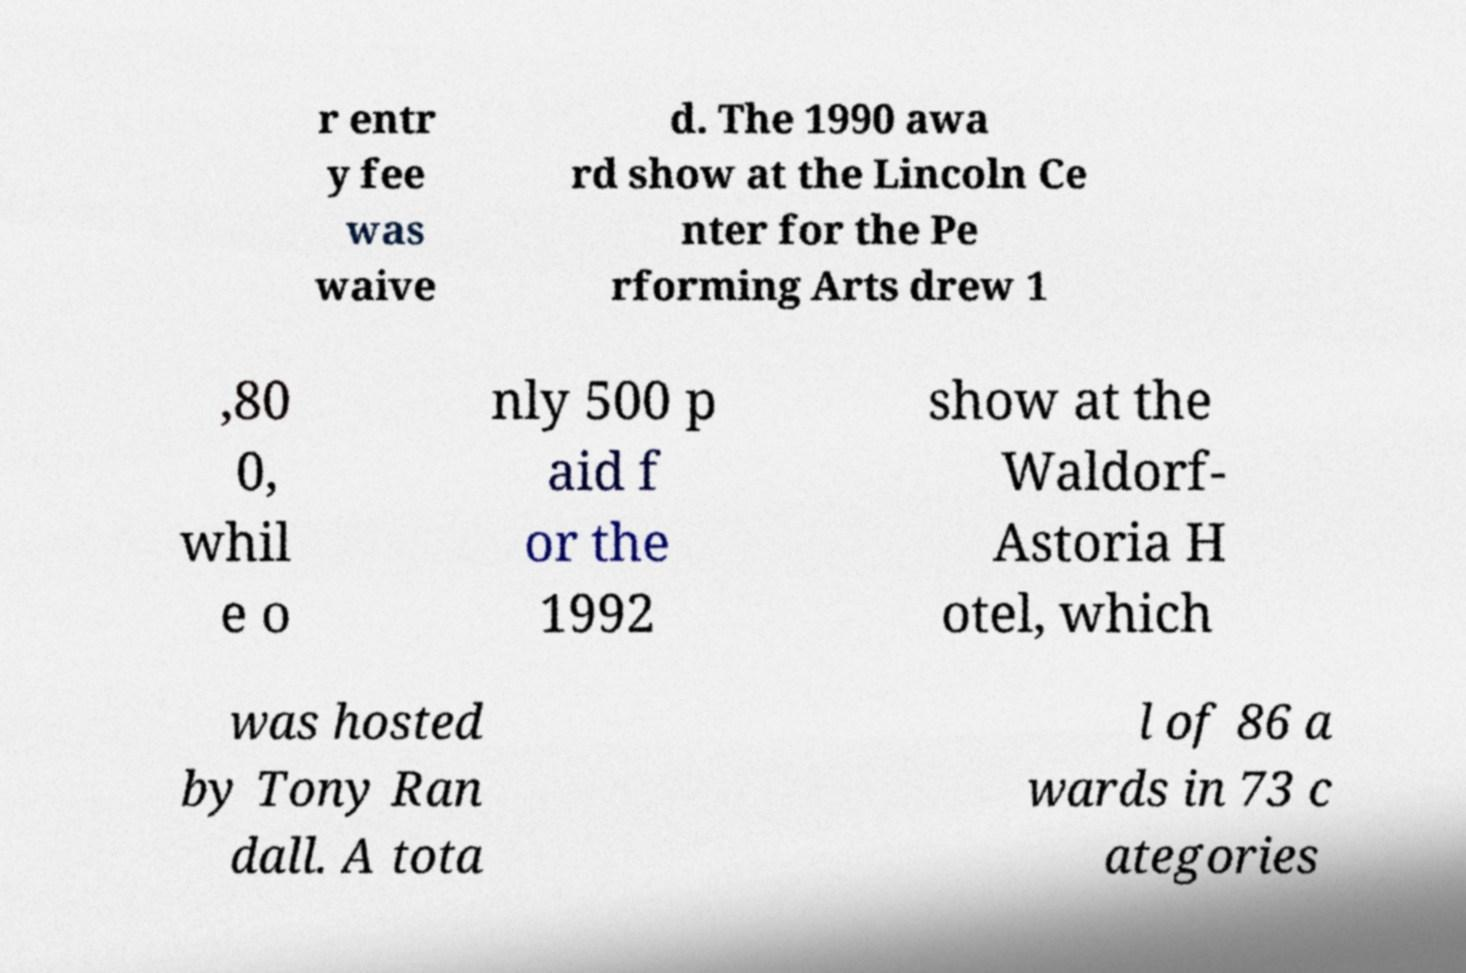Please identify and transcribe the text found in this image. r entr y fee was waive d. The 1990 awa rd show at the Lincoln Ce nter for the Pe rforming Arts drew 1 ,80 0, whil e o nly 500 p aid f or the 1992 show at the Waldorf- Astoria H otel, which was hosted by Tony Ran dall. A tota l of 86 a wards in 73 c ategories 